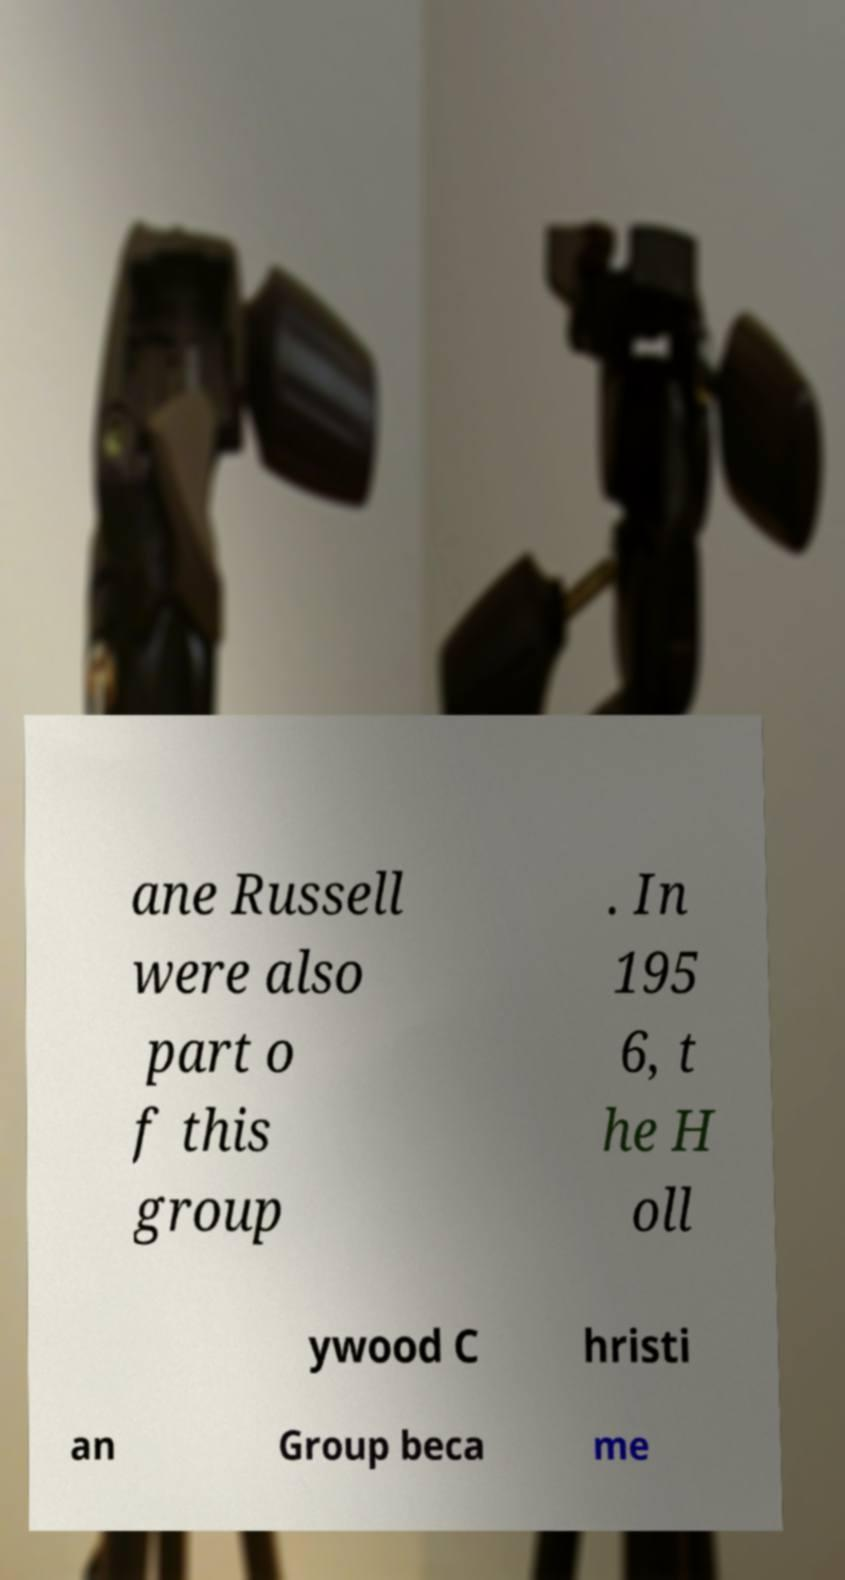Could you extract and type out the text from this image? ane Russell were also part o f this group . In 195 6, t he H oll ywood C hristi an Group beca me 